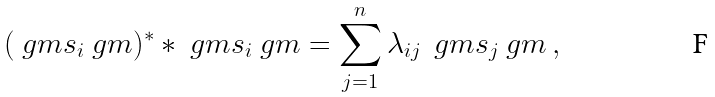Convert formula to latex. <formula><loc_0><loc_0><loc_500><loc_500>( \ g m s _ { i } \ g m ) ^ { * } * \ g m s _ { i } \ g m = \sum _ { j = 1 } ^ { n } \lambda _ { i j } \, \ g m s _ { j } \ g m \, ,</formula> 